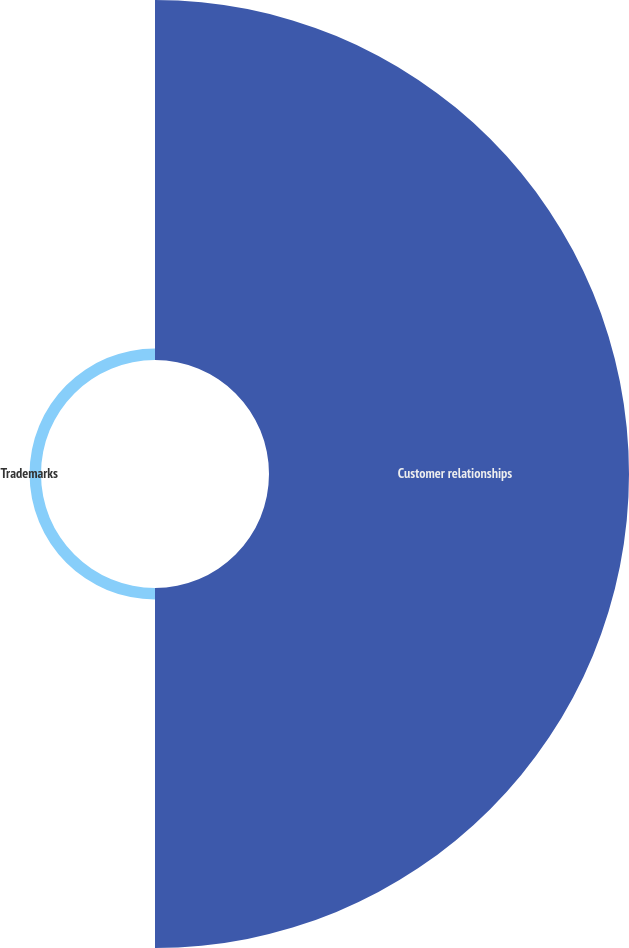<chart> <loc_0><loc_0><loc_500><loc_500><pie_chart><fcel>Customer relationships<fcel>Trademarks<nl><fcel>96.92%<fcel>3.08%<nl></chart> 